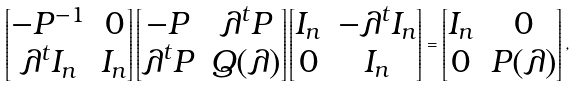<formula> <loc_0><loc_0><loc_500><loc_500>\begin{bmatrix} - P ^ { - 1 } & 0 \\ \lambda ^ { t } I _ { n } & I _ { n } \end{bmatrix} \begin{bmatrix} - P & \lambda ^ { t } P \\ \lambda ^ { t } P & Q ( \lambda ) \end{bmatrix} \begin{bmatrix} I _ { n } & - \lambda ^ { t } I _ { n } \\ 0 & I _ { n } \end{bmatrix} = \begin{bmatrix} I _ { n } & 0 \\ 0 & P ( \lambda ) \end{bmatrix} ,</formula> 